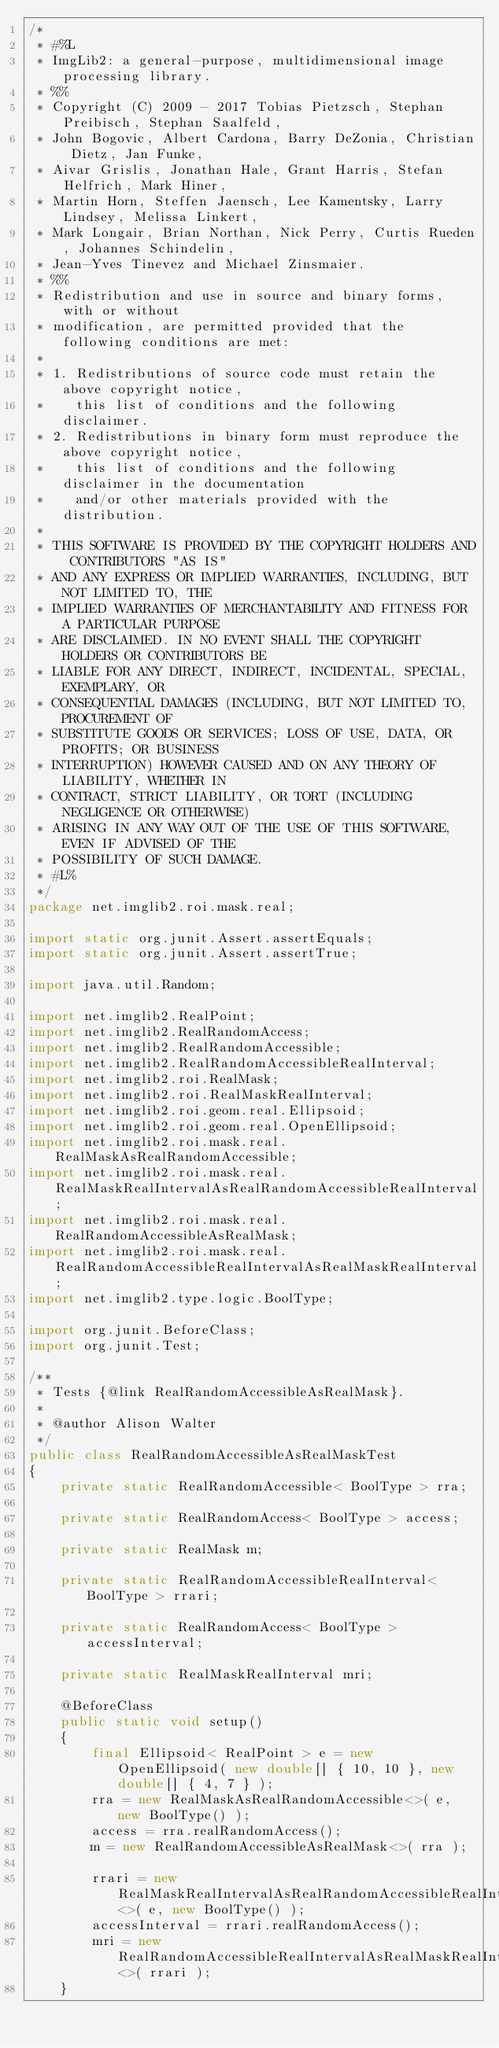Convert code to text. <code><loc_0><loc_0><loc_500><loc_500><_Java_>/*
 * #%L
 * ImgLib2: a general-purpose, multidimensional image processing library.
 * %%
 * Copyright (C) 2009 - 2017 Tobias Pietzsch, Stephan Preibisch, Stephan Saalfeld,
 * John Bogovic, Albert Cardona, Barry DeZonia, Christian Dietz, Jan Funke,
 * Aivar Grislis, Jonathan Hale, Grant Harris, Stefan Helfrich, Mark Hiner,
 * Martin Horn, Steffen Jaensch, Lee Kamentsky, Larry Lindsey, Melissa Linkert,
 * Mark Longair, Brian Northan, Nick Perry, Curtis Rueden, Johannes Schindelin,
 * Jean-Yves Tinevez and Michael Zinsmaier.
 * %%
 * Redistribution and use in source and binary forms, with or without
 * modification, are permitted provided that the following conditions are met:
 * 
 * 1. Redistributions of source code must retain the above copyright notice,
 *    this list of conditions and the following disclaimer.
 * 2. Redistributions in binary form must reproduce the above copyright notice,
 *    this list of conditions and the following disclaimer in the documentation
 *    and/or other materials provided with the distribution.
 * 
 * THIS SOFTWARE IS PROVIDED BY THE COPYRIGHT HOLDERS AND CONTRIBUTORS "AS IS"
 * AND ANY EXPRESS OR IMPLIED WARRANTIES, INCLUDING, BUT NOT LIMITED TO, THE
 * IMPLIED WARRANTIES OF MERCHANTABILITY AND FITNESS FOR A PARTICULAR PURPOSE
 * ARE DISCLAIMED. IN NO EVENT SHALL THE COPYRIGHT HOLDERS OR CONTRIBUTORS BE
 * LIABLE FOR ANY DIRECT, INDIRECT, INCIDENTAL, SPECIAL, EXEMPLARY, OR
 * CONSEQUENTIAL DAMAGES (INCLUDING, BUT NOT LIMITED TO, PROCUREMENT OF
 * SUBSTITUTE GOODS OR SERVICES; LOSS OF USE, DATA, OR PROFITS; OR BUSINESS
 * INTERRUPTION) HOWEVER CAUSED AND ON ANY THEORY OF LIABILITY, WHETHER IN
 * CONTRACT, STRICT LIABILITY, OR TORT (INCLUDING NEGLIGENCE OR OTHERWISE)
 * ARISING IN ANY WAY OUT OF THE USE OF THIS SOFTWARE, EVEN IF ADVISED OF THE
 * POSSIBILITY OF SUCH DAMAGE.
 * #L%
 */
package net.imglib2.roi.mask.real;

import static org.junit.Assert.assertEquals;
import static org.junit.Assert.assertTrue;

import java.util.Random;

import net.imglib2.RealPoint;
import net.imglib2.RealRandomAccess;
import net.imglib2.RealRandomAccessible;
import net.imglib2.RealRandomAccessibleRealInterval;
import net.imglib2.roi.RealMask;
import net.imglib2.roi.RealMaskRealInterval;
import net.imglib2.roi.geom.real.Ellipsoid;
import net.imglib2.roi.geom.real.OpenEllipsoid;
import net.imglib2.roi.mask.real.RealMaskAsRealRandomAccessible;
import net.imglib2.roi.mask.real.RealMaskRealIntervalAsRealRandomAccessibleRealInterval;
import net.imglib2.roi.mask.real.RealRandomAccessibleAsRealMask;
import net.imglib2.roi.mask.real.RealRandomAccessibleRealIntervalAsRealMaskRealInterval;
import net.imglib2.type.logic.BoolType;

import org.junit.BeforeClass;
import org.junit.Test;

/**
 * Tests {@link RealRandomAccessibleAsRealMask}.
 *
 * @author Alison Walter
 */
public class RealRandomAccessibleAsRealMaskTest
{
	private static RealRandomAccessible< BoolType > rra;

	private static RealRandomAccess< BoolType > access;

	private static RealMask m;

	private static RealRandomAccessibleRealInterval< BoolType > rrari;

	private static RealRandomAccess< BoolType > accessInterval;

	private static RealMaskRealInterval mri;

	@BeforeClass
	public static void setup()
	{
		final Ellipsoid< RealPoint > e = new OpenEllipsoid( new double[] { 10, 10 }, new double[] { 4, 7 } );
		rra = new RealMaskAsRealRandomAccessible<>( e, new BoolType() );
		access = rra.realRandomAccess();
		m = new RealRandomAccessibleAsRealMask<>( rra );

		rrari = new RealMaskRealIntervalAsRealRandomAccessibleRealInterval<>( e, new BoolType() );
		accessInterval = rrari.realRandomAccess();
		mri = new RealRandomAccessibleRealIntervalAsRealMaskRealInterval<>( rrari );
	}
</code> 